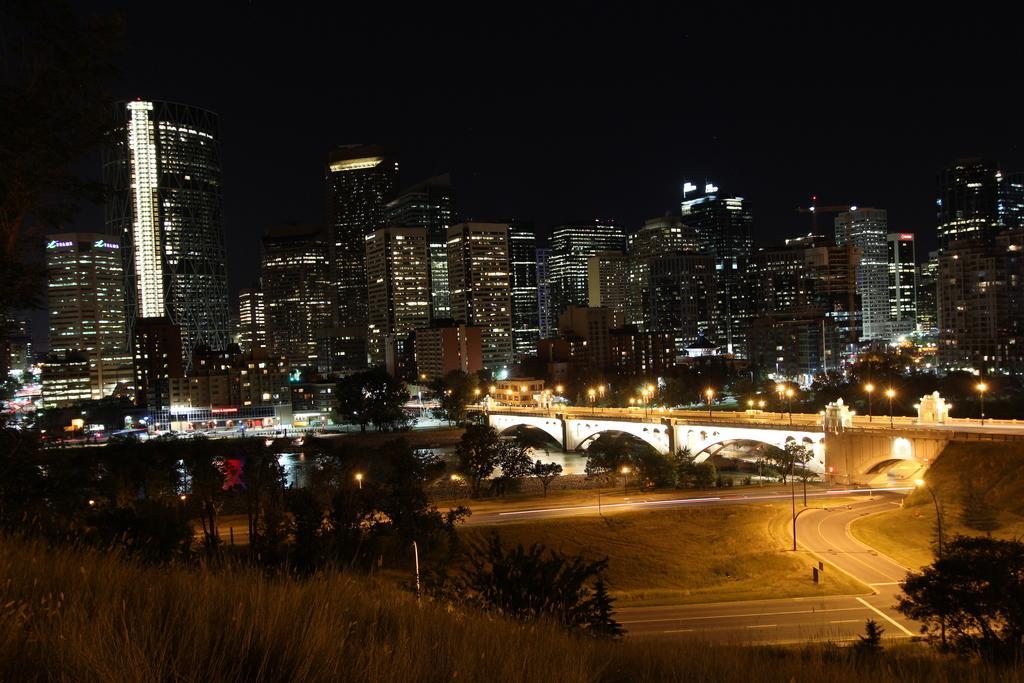Can you describe this image briefly? As we can see in the image there are trees, water, bridge, lights, buildings and the image is little dark. 